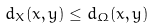<formula> <loc_0><loc_0><loc_500><loc_500>d _ { X } ( x , y ) \leq d _ { \Omega } ( x , y )</formula> 